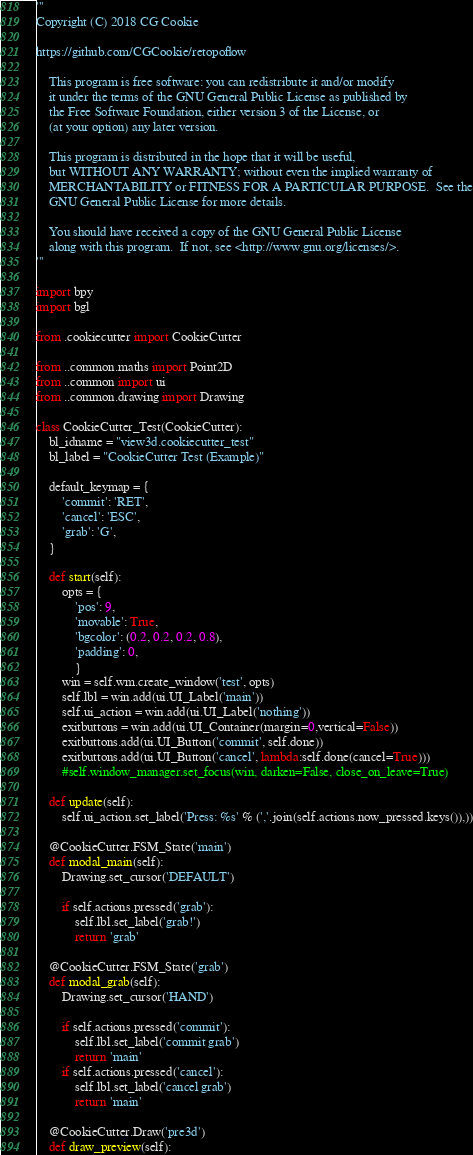<code> <loc_0><loc_0><loc_500><loc_500><_Python_>'''
Copyright (C) 2018 CG Cookie

https://github.com/CGCookie/retopoflow

    This program is free software: you can redistribute it and/or modify
    it under the terms of the GNU General Public License as published by
    the Free Software Foundation, either version 3 of the License, or
    (at your option) any later version.

    This program is distributed in the hope that it will be useful,
    but WITHOUT ANY WARRANTY; without even the implied warranty of
    MERCHANTABILITY or FITNESS FOR A PARTICULAR PURPOSE.  See the
    GNU General Public License for more details.

    You should have received a copy of the GNU General Public License
    along with this program.  If not, see <http://www.gnu.org/licenses/>.
'''

import bpy
import bgl

from .cookiecutter import CookieCutter

from ..common.maths import Point2D
from ..common import ui
from ..common.drawing import Drawing

class CookieCutter_Test(CookieCutter):
    bl_idname = "view3d.cookiecutter_test"
    bl_label = "CookieCutter Test (Example)"

    default_keymap = {
        'commit': 'RET',
        'cancel': 'ESC',
        'grab': 'G',
    }

    def start(self):
        opts = {
            'pos': 9,
            'movable': True,
            'bgcolor': (0.2, 0.2, 0.2, 0.8),
            'padding': 0,
            }
        win = self.wm.create_window('test', opts)
        self.lbl = win.add(ui.UI_Label('main'))
        self.ui_action = win.add(ui.UI_Label('nothing'))
        exitbuttons = win.add(ui.UI_Container(margin=0,vertical=False))
        exitbuttons.add(ui.UI_Button('commit', self.done))
        exitbuttons.add(ui.UI_Button('cancel', lambda:self.done(cancel=True)))
        #self.window_manager.set_focus(win, darken=False, close_on_leave=True)

    def update(self):
        self.ui_action.set_label('Press: %s' % (','.join(self.actions.now_pressed.keys()),))

    @CookieCutter.FSM_State('main')
    def modal_main(self):
        Drawing.set_cursor('DEFAULT')

        if self.actions.pressed('grab'):
            self.lbl.set_label('grab!')
            return 'grab'

    @CookieCutter.FSM_State('grab')
    def modal_grab(self):
        Drawing.set_cursor('HAND')

        if self.actions.pressed('commit'):
            self.lbl.set_label('commit grab')
            return 'main'
        if self.actions.pressed('cancel'):
            self.lbl.set_label('cancel grab')
            return 'main'

    @CookieCutter.Draw('pre3d')
    def draw_preview(self):</code> 